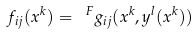Convert formula to latex. <formula><loc_0><loc_0><loc_500><loc_500>f _ { i j } ( x ^ { k } ) = \ ^ { F } g _ { i j } ( x ^ { k } , y ^ { l } ( x ^ { k } ) )</formula> 